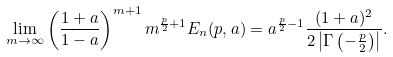Convert formula to latex. <formula><loc_0><loc_0><loc_500><loc_500>\lim _ { m \to \infty } \left ( \frac { 1 + a } { 1 - a } \right ) ^ { m + 1 } m ^ { \frac { p } { 2 } + 1 } E _ { n } ( p , a ) = { a } ^ { \frac { p } { 2 } - 1 } \frac { ( 1 + a ) ^ { 2 } } { 2 \left | \Gamma \left ( - \frac { p } { 2 } \right ) \right | } .</formula> 